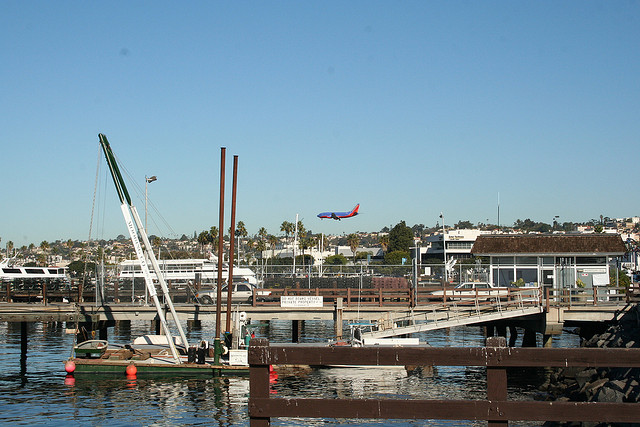What activities might be popular in this location? Given the presence of the marina, boating, and sailing are likely popular activities. The docks provide an ideal location for fishing, enjoying leisurely walks, or simply appreciating the ocean view. The proximity to the city could also mean dining or shopping at waterfront establishments is a common pastime. 